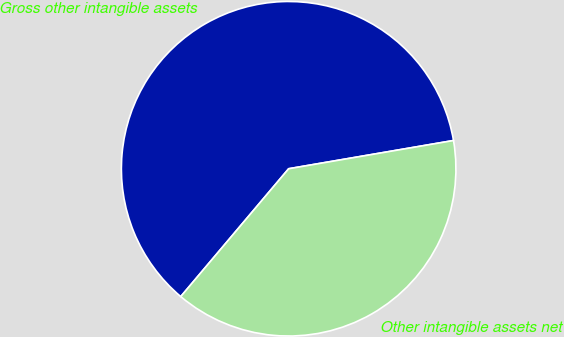Convert chart to OTSL. <chart><loc_0><loc_0><loc_500><loc_500><pie_chart><fcel>Gross other intangible assets<fcel>Other intangible assets net<nl><fcel>61.14%<fcel>38.86%<nl></chart> 